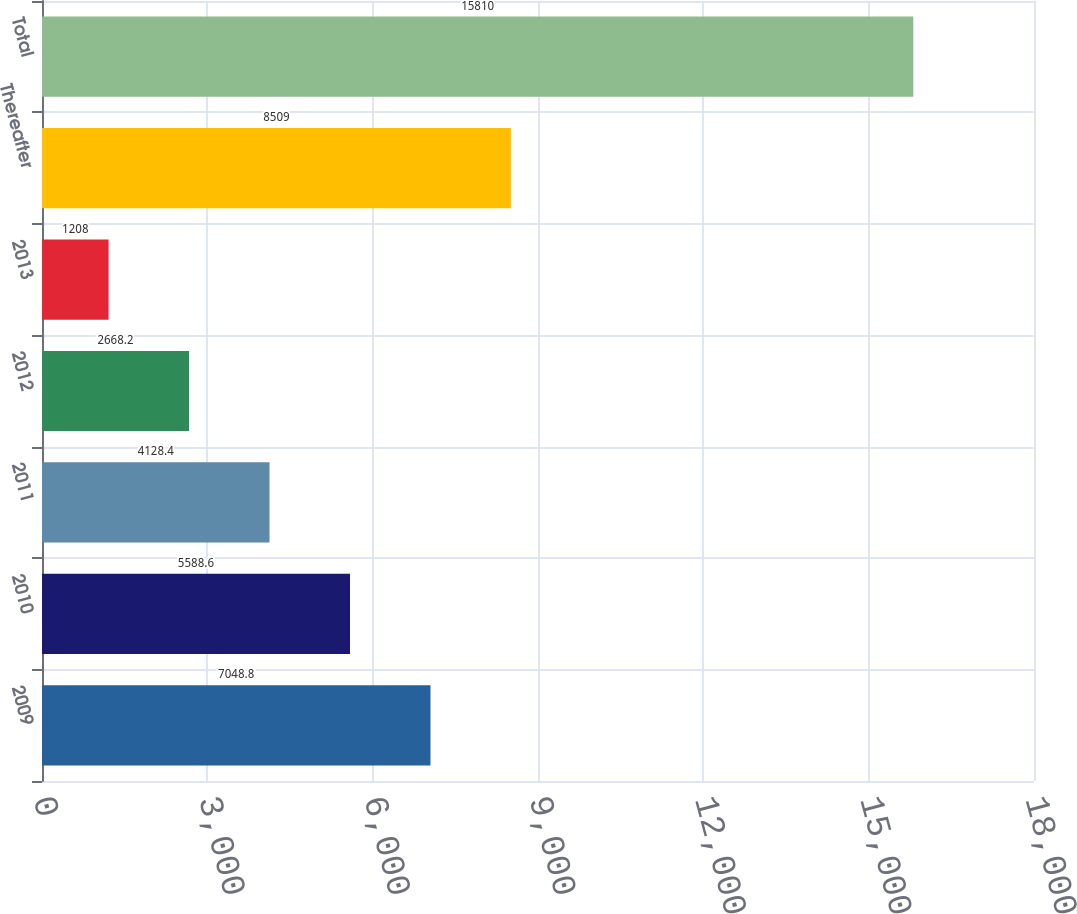<chart> <loc_0><loc_0><loc_500><loc_500><bar_chart><fcel>2009<fcel>2010<fcel>2011<fcel>2012<fcel>2013<fcel>Thereafter<fcel>Total<nl><fcel>7048.8<fcel>5588.6<fcel>4128.4<fcel>2668.2<fcel>1208<fcel>8509<fcel>15810<nl></chart> 